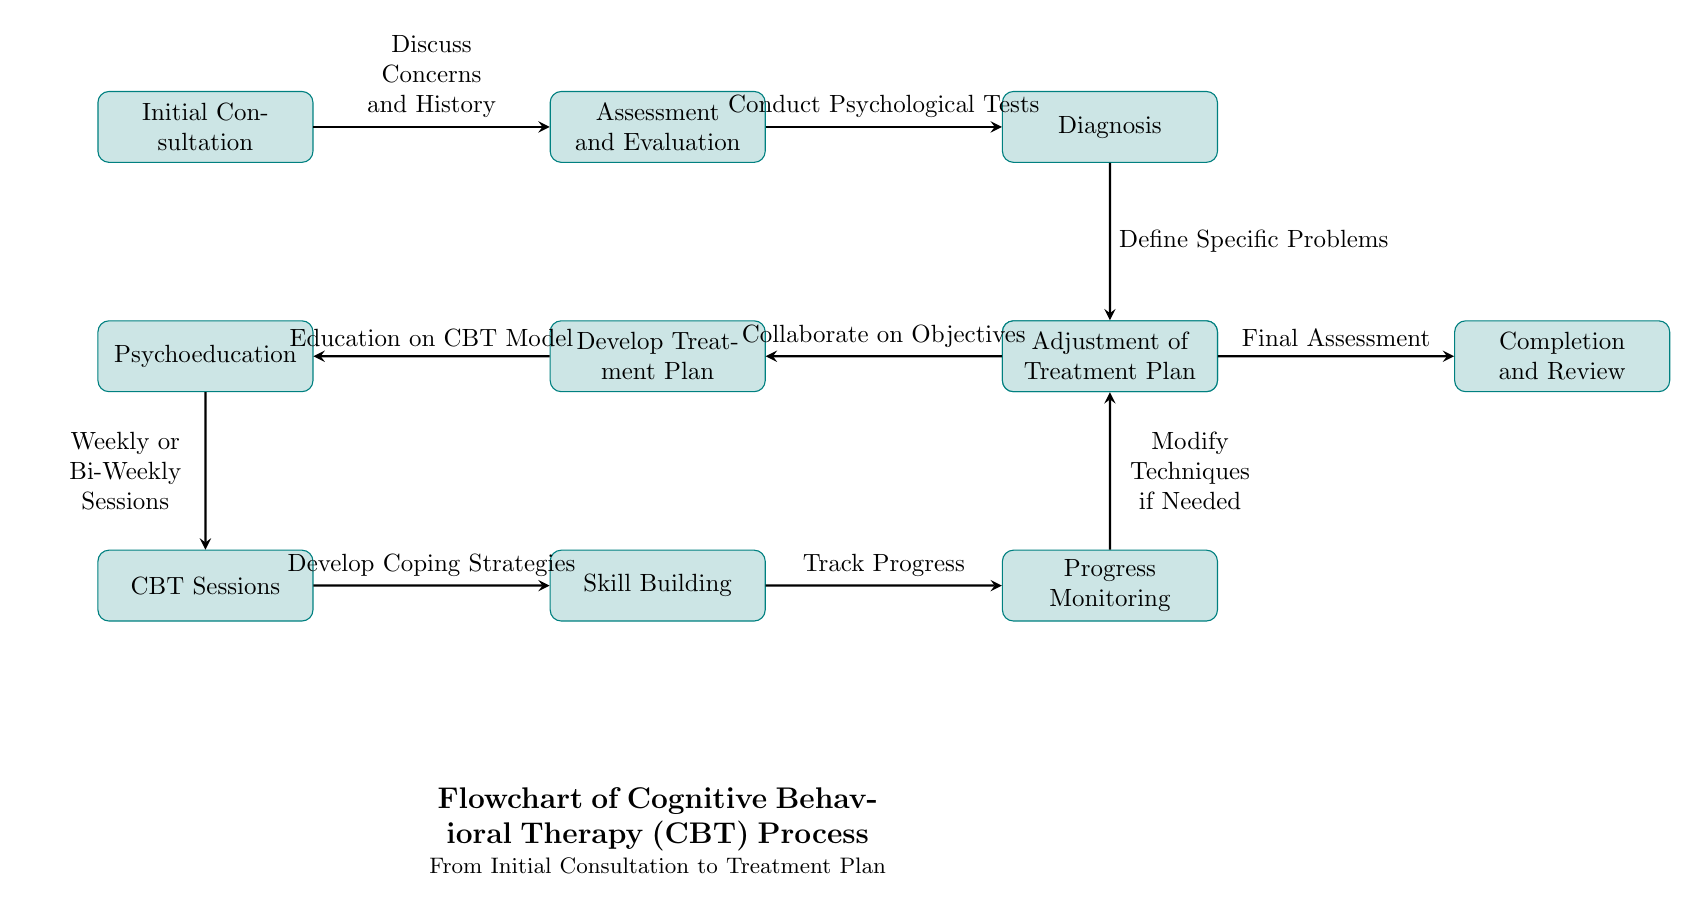What is the first step in the CBT process? The first step in the CBT process, as represented in the diagram, is "Initial Consultation," which is the starting point for patients seeking therapy.
Answer: Initial Consultation How many main steps are there in the CBT process? By counting the nodes in the diagram, there are a total of 11 main steps depicted in the CBT process, each representing a significant stage in patient treatment.
Answer: 11 What process follows "Diagnosis"? According to the arrows connecting the nodes in the diagram, the process that follows "Diagnosis" is "Goal Setting," indicating the shift towards establishing objectives for therapy.
Answer: Goal Setting What does "Psychoeducation" lead to in the next step? In the flowchart, "Psychoeducation" leads to "CBT Sessions." This indicates that education on CBT follows the understanding of the treatment model.
Answer: CBT Sessions What type of sessions are indicated after "Psychoeducation"? The diagram shows that the therapy sessions indicated after "Psychoeducation" are labeled as "Weekly or Bi-Weekly Sessions," suggesting the frequency of patient meetings.
Answer: Weekly or Bi-Weekly Sessions What is the purpose of the "Progress Monitoring" step? The step "Progress Monitoring" serves to "Track Progress," which means it is meant to assess the advancements made by the patient during treatment.
Answer: Track Progress Which step involves modifying techniques if needed? The "Adjustment of Treatment Plan" involves modifying techniques if needed, as indicated by the flow connection leading from "Progress Monitoring."
Answer: Adjustment of Treatment Plan What occurs after the "Completion and Review"? After "Completion and Review," there are no subsequent steps indicated in the diagram, showing that this is the final step of the CBT process.
Answer: None 